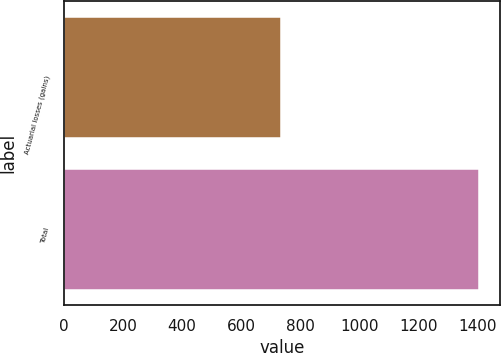Convert chart. <chart><loc_0><loc_0><loc_500><loc_500><bar_chart><fcel>Actuarial losses (gains)<fcel>Total<nl><fcel>736<fcel>1406<nl></chart> 